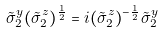<formula> <loc_0><loc_0><loc_500><loc_500>\tilde { \sigma } ^ { y } _ { 2 } ( \tilde { \sigma } ^ { z } _ { 2 } ) ^ { \frac { 1 } { 2 } } = i ( \tilde { \sigma } ^ { z } _ { 2 } ) ^ { - \frac { 1 } { 2 } } \tilde { \sigma } ^ { y } _ { 2 }</formula> 